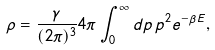Convert formula to latex. <formula><loc_0><loc_0><loc_500><loc_500>\rho = \frac { \gamma } { ( 2 \pi ) ^ { 3 } } 4 \pi \int _ { 0 } ^ { \infty } d p \, p ^ { 2 } e ^ { - \beta E } ,</formula> 